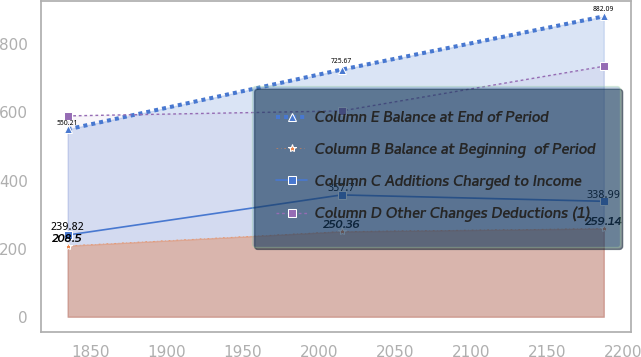Convert chart. <chart><loc_0><loc_0><loc_500><loc_500><line_chart><ecel><fcel>Column E Balance at End of Period<fcel>Column B Balance at Beginning  of Period<fcel>Column C Additions Charged to Income<fcel>Column D Other Changes Deductions (1)<nl><fcel>1834.81<fcel>550.21<fcel>208.5<fcel>239.82<fcel>589.77<nl><fcel>2014.82<fcel>725.67<fcel>250.36<fcel>357.7<fcel>604.34<nl><fcel>2187.19<fcel>882.09<fcel>259.14<fcel>338.99<fcel>735.47<nl></chart> 